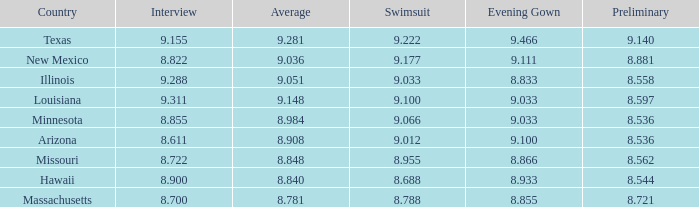What was the swimsuit score for the country with the average score of 8.848? 8.955. 